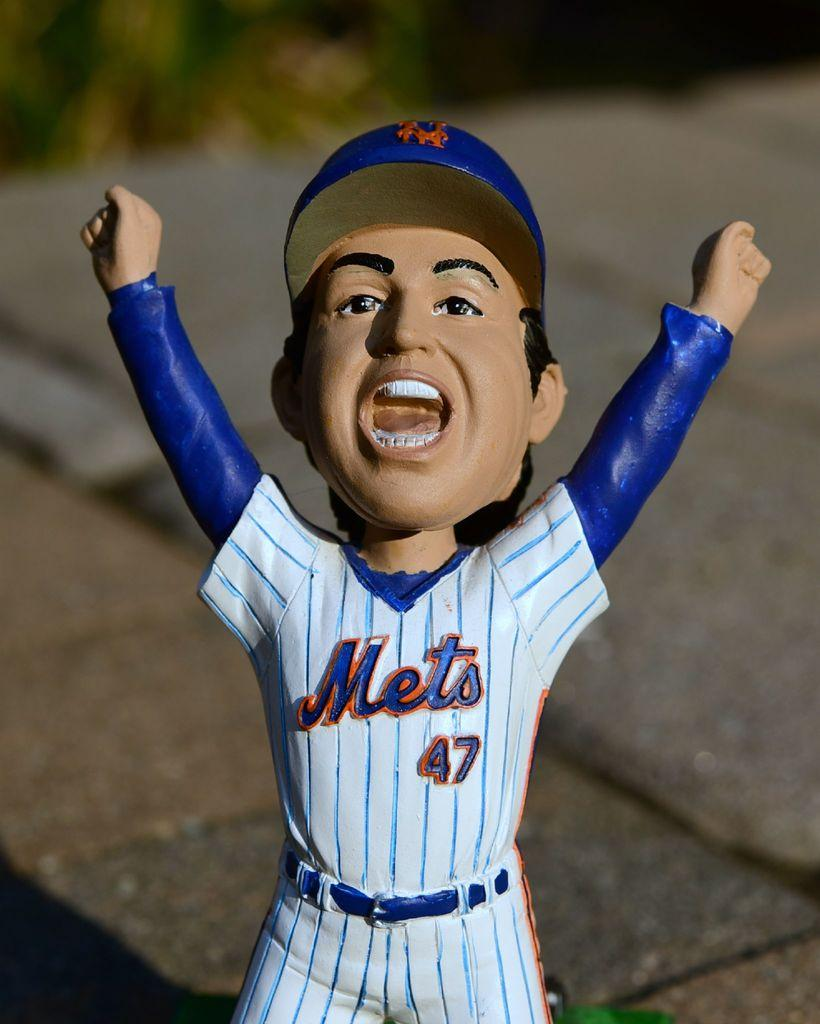<image>
Share a concise interpretation of the image provided. A bobble head figurine of a baseball player has a uniform that says Mets 47 and his arms are raised in the air. 